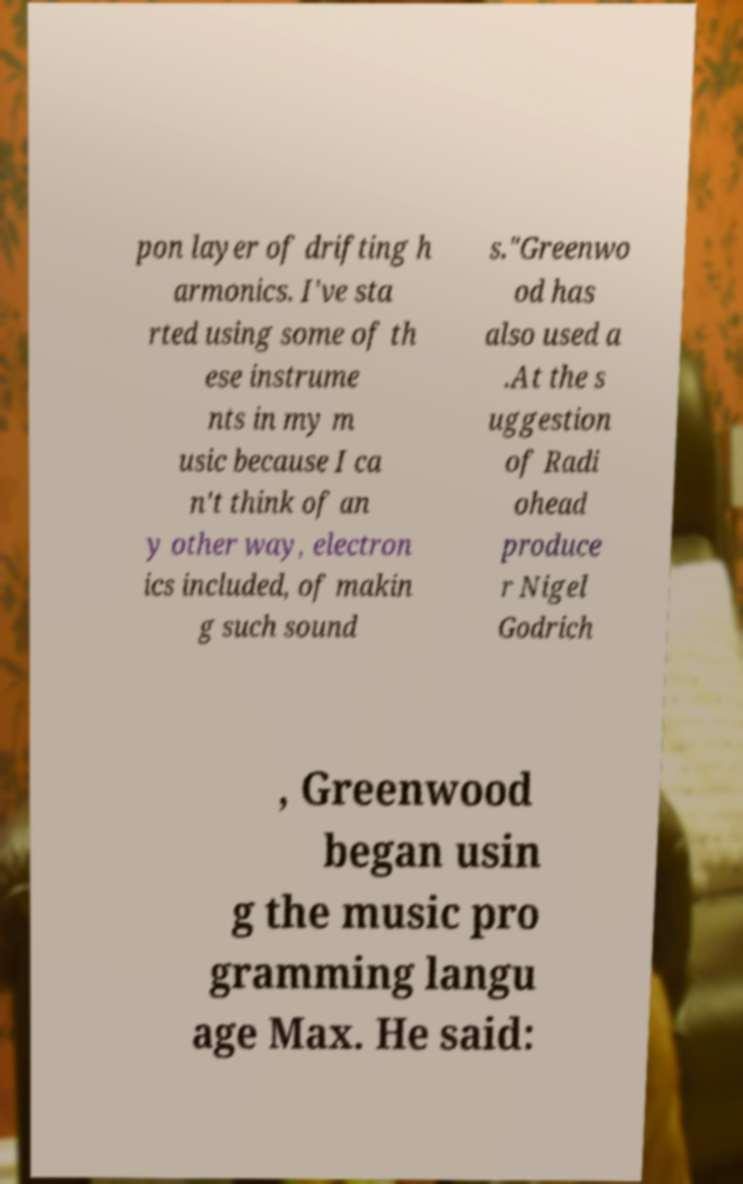There's text embedded in this image that I need extracted. Can you transcribe it verbatim? pon layer of drifting h armonics. I've sta rted using some of th ese instrume nts in my m usic because I ca n't think of an y other way, electron ics included, of makin g such sound s."Greenwo od has also used a .At the s uggestion of Radi ohead produce r Nigel Godrich , Greenwood began usin g the music pro gramming langu age Max. He said: 